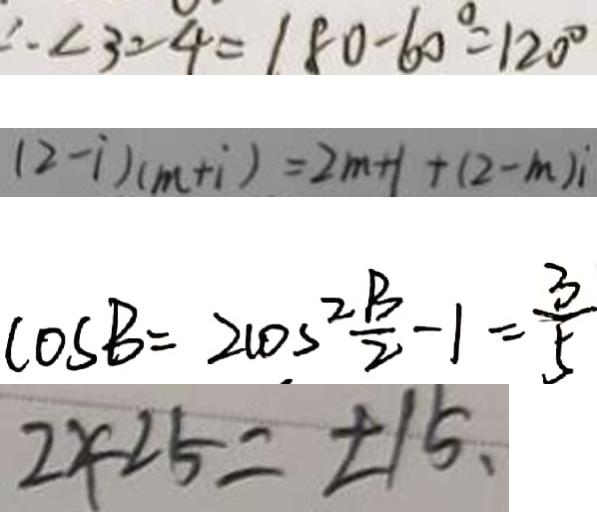Convert formula to latex. <formula><loc_0><loc_0><loc_500><loc_500>\therefore \angle 3 = 4 = 1 8 0 - 6 0 ^ { \circ } = 1 2 0 ^ { \circ } 
 ( 2 - i ) ( m + i ) = 2 m + 1 + ( 2 - m ) i 
 \cos B = 2 \cos ^ { 2 } \frac { B } { 2 } - 1 = \frac { 3 } { 5 } 
 2 < 2 5 = \pm 1 5 、</formula> 